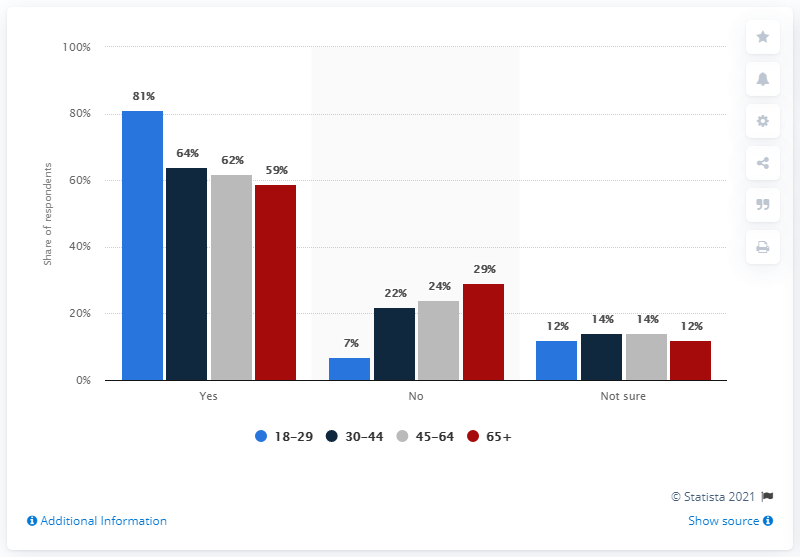What do the colors of the bars represent? The colors of the bars represent different age groups which participated in the survey. For instance, the blue bars correspond to the age group 18-29, grey bars to the age group 30-44, red bars to 45-64, and dark red bars to those aged 65 and above. 